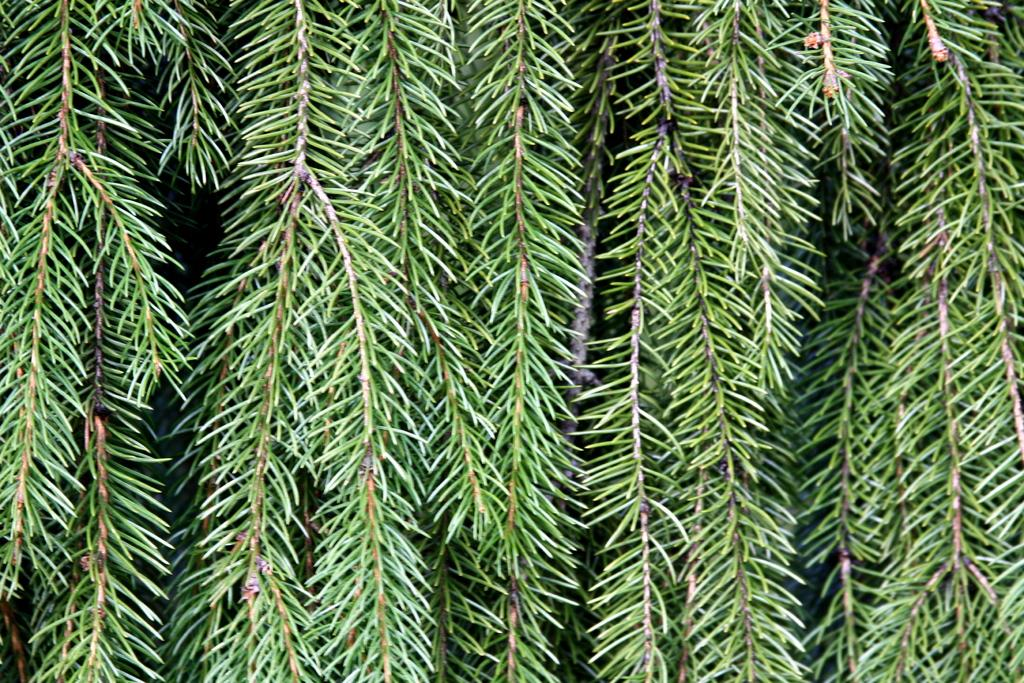What type of natural elements can be seen in the image? There are tree branches in the image. What is the color of the tree branches? The tree branches are green in color. What type of song is being sung by the father in the image? There is no father or song present in the image; it only features tree branches. 